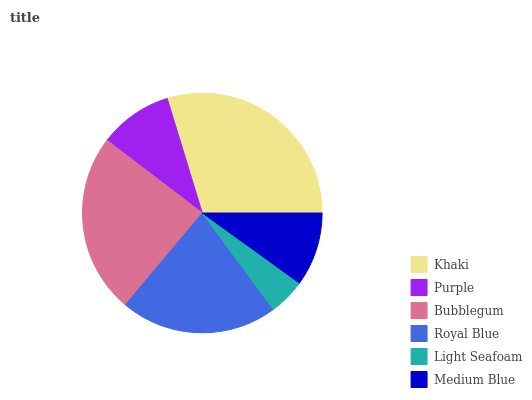Is Light Seafoam the minimum?
Answer yes or no. Yes. Is Khaki the maximum?
Answer yes or no. Yes. Is Purple the minimum?
Answer yes or no. No. Is Purple the maximum?
Answer yes or no. No. Is Khaki greater than Purple?
Answer yes or no. Yes. Is Purple less than Khaki?
Answer yes or no. Yes. Is Purple greater than Khaki?
Answer yes or no. No. Is Khaki less than Purple?
Answer yes or no. No. Is Royal Blue the high median?
Answer yes or no. Yes. Is Medium Blue the low median?
Answer yes or no. Yes. Is Medium Blue the high median?
Answer yes or no. No. Is Royal Blue the low median?
Answer yes or no. No. 